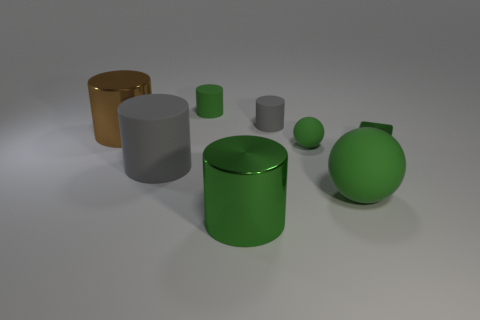Subtract 1 cylinders. How many cylinders are left? 4 Subtract all green matte cylinders. How many cylinders are left? 4 Subtract all brown cylinders. How many cylinders are left? 4 Subtract all cyan cylinders. Subtract all yellow spheres. How many cylinders are left? 5 Add 2 tiny green cylinders. How many objects exist? 10 Subtract all balls. How many objects are left? 6 Subtract 0 yellow spheres. How many objects are left? 8 Subtract all shiny cylinders. Subtract all blue metal cylinders. How many objects are left? 6 Add 4 big green objects. How many big green objects are left? 6 Add 6 big brown shiny spheres. How many big brown shiny spheres exist? 6 